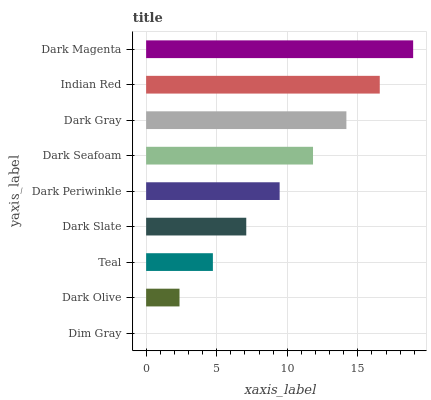Is Dim Gray the minimum?
Answer yes or no. Yes. Is Dark Magenta the maximum?
Answer yes or no. Yes. Is Dark Olive the minimum?
Answer yes or no. No. Is Dark Olive the maximum?
Answer yes or no. No. Is Dark Olive greater than Dim Gray?
Answer yes or no. Yes. Is Dim Gray less than Dark Olive?
Answer yes or no. Yes. Is Dim Gray greater than Dark Olive?
Answer yes or no. No. Is Dark Olive less than Dim Gray?
Answer yes or no. No. Is Dark Periwinkle the high median?
Answer yes or no. Yes. Is Dark Periwinkle the low median?
Answer yes or no. Yes. Is Dark Olive the high median?
Answer yes or no. No. Is Dark Magenta the low median?
Answer yes or no. No. 